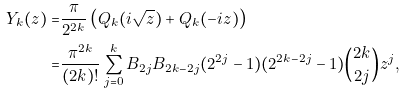<formula> <loc_0><loc_0><loc_500><loc_500>Y _ { k } ( z ) = & \frac { \pi } { 2 ^ { 2 k } } \left ( Q _ { k } ( i \sqrt { z } ) + Q _ { k } ( - i z ) \right ) \\ = & \frac { \pi ^ { 2 k } } { ( 2 k ) ! } \sum _ { j = 0 } ^ { k } B _ { 2 j } B _ { 2 k - 2 j } ( 2 ^ { 2 j } - 1 ) ( 2 ^ { 2 k - 2 j } - 1 ) \binom { 2 k } { 2 j } z ^ { j } ,</formula> 